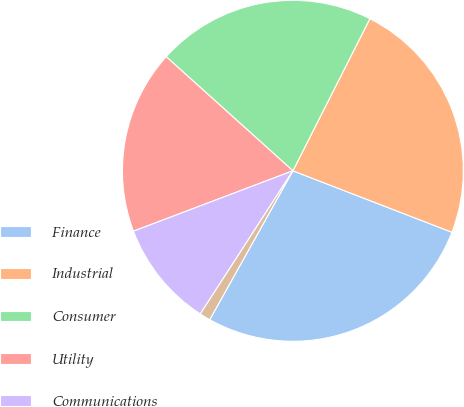Convert chart. <chart><loc_0><loc_0><loc_500><loc_500><pie_chart><fcel>Finance<fcel>Industrial<fcel>Consumer<fcel>Utility<fcel>Communications<fcel>Other<nl><fcel>27.24%<fcel>23.41%<fcel>20.79%<fcel>17.43%<fcel>10.1%<fcel>1.03%<nl></chart> 